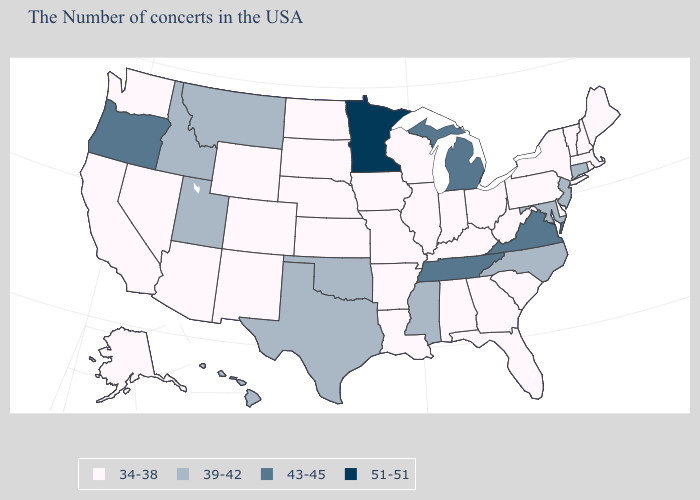What is the lowest value in the Northeast?
Be succinct. 34-38. Name the states that have a value in the range 39-42?
Give a very brief answer. Connecticut, New Jersey, Maryland, North Carolina, Mississippi, Oklahoma, Texas, Utah, Montana, Idaho, Hawaii. Which states hav the highest value in the MidWest?
Short answer required. Minnesota. Name the states that have a value in the range 39-42?
Quick response, please. Connecticut, New Jersey, Maryland, North Carolina, Mississippi, Oklahoma, Texas, Utah, Montana, Idaho, Hawaii. What is the value of South Carolina?
Keep it brief. 34-38. What is the value of Tennessee?
Give a very brief answer. 43-45. What is the value of Tennessee?
Quick response, please. 43-45. What is the value of Iowa?
Give a very brief answer. 34-38. What is the lowest value in states that border Connecticut?
Keep it brief. 34-38. What is the value of Texas?
Answer briefly. 39-42. Does Maine have a lower value than Texas?
Short answer required. Yes. Name the states that have a value in the range 51-51?
Write a very short answer. Minnesota. Does Virginia have the lowest value in the USA?
Concise answer only. No. Which states hav the highest value in the MidWest?
Give a very brief answer. Minnesota. Is the legend a continuous bar?
Write a very short answer. No. 